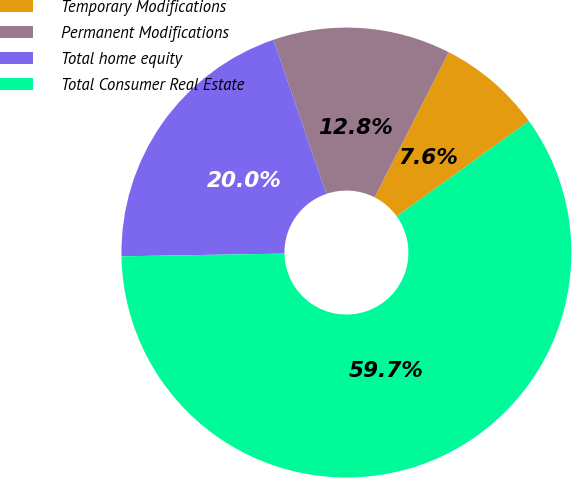Convert chart to OTSL. <chart><loc_0><loc_0><loc_500><loc_500><pie_chart><fcel>Temporary Modifications<fcel>Permanent Modifications<fcel>Total home equity<fcel>Total Consumer Real Estate<nl><fcel>7.55%<fcel>12.77%<fcel>20.01%<fcel>59.67%<nl></chart> 